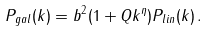Convert formula to latex. <formula><loc_0><loc_0><loc_500><loc_500>P _ { g a l } ( k ) = b ^ { 2 } ( 1 + Q k ^ { \eta } ) P _ { l i n } ( k ) \, .</formula> 